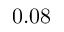Convert formula to latex. <formula><loc_0><loc_0><loc_500><loc_500>0 . 0 8</formula> 